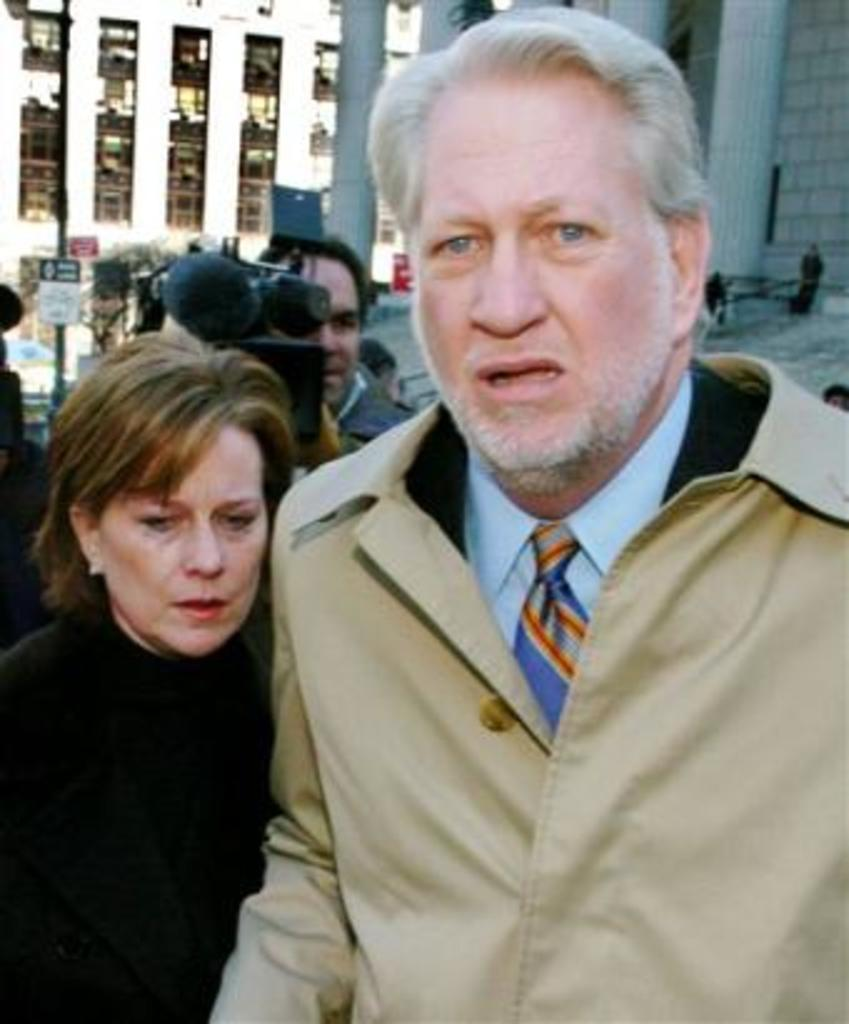What can be observed about the attire of the people in the image? There are people wearing different color dresses in the image. What is one person doing in the image? One person is holding something. What can be seen in the distance in the image? There are buildings, a window, pillars, signboards, and trees visible in the background of the image. Is there a stream visible in the image? No, there is no stream present in the image. What type of war is being depicted in the image? There is no depiction of war in the image; it features people wearing different color dresses and various elements in the background. 